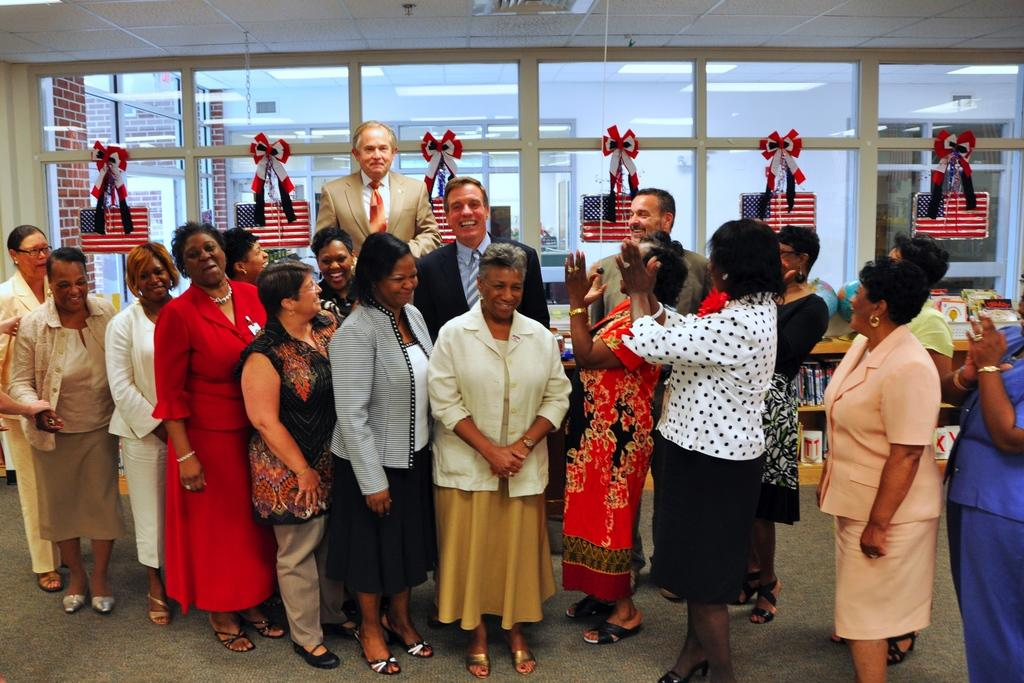What architectural feature can be seen in the image? There are windows and a wall visible in the image. Can you describe the group of people in the image? There is a group of people standing in the image. How many bridges can be seen in the image? There are no bridges present in the image. Does the existence of the group of people in the image prove the existence of extraterrestrial life? The presence of the group of people in the image does not prove the existence of extraterrestrial life, as they appear to be human. 